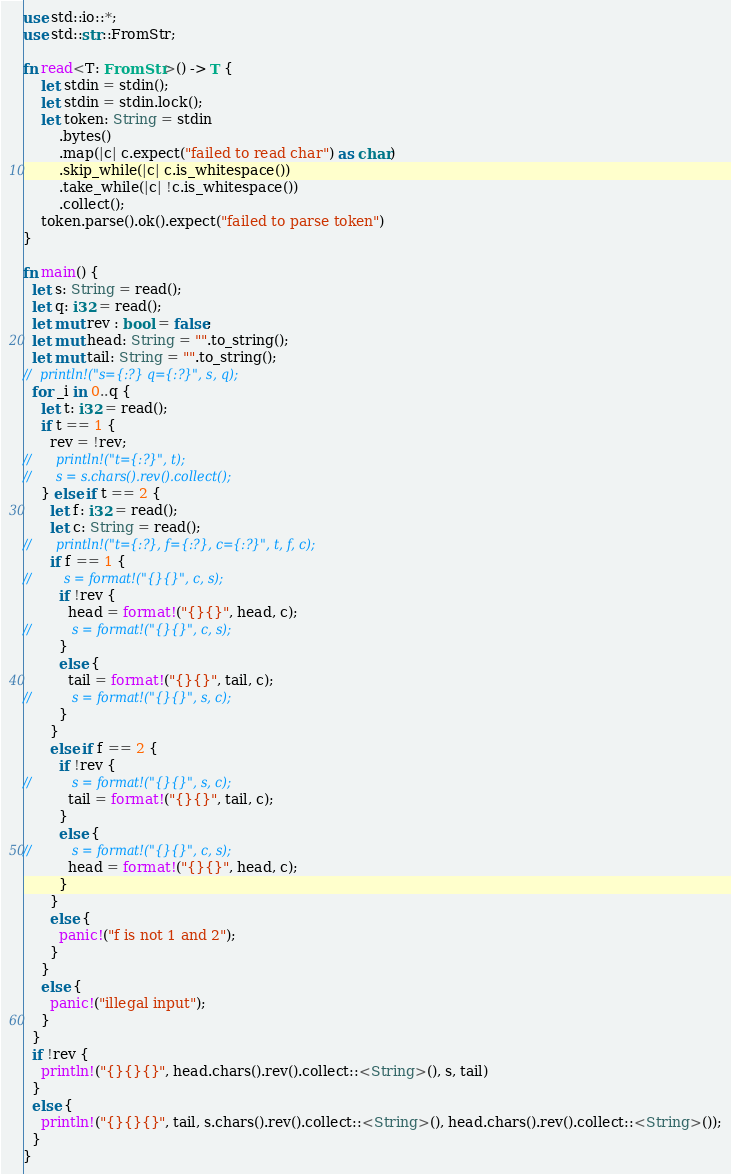Convert code to text. <code><loc_0><loc_0><loc_500><loc_500><_Rust_>use std::io::*;
use std::str::FromStr;

fn read<T: FromStr>() -> T {
    let stdin = stdin();
    let stdin = stdin.lock();
    let token: String = stdin
        .bytes()
        .map(|c| c.expect("failed to read char") as char)
        .skip_while(|c| c.is_whitespace())
        .take_while(|c| !c.is_whitespace())
        .collect();
    token.parse().ok().expect("failed to parse token")
}

fn main() {
  let s: String = read();
  let q: i32 = read();
  let mut rev : bool = false;
  let mut head: String = "".to_string();
  let mut tail: String = "".to_string();
//  println!("s={:?} q={:?}", s, q);
  for _i in 0..q {
    let t: i32 = read();
    if t == 1 {
      rev = !rev;
//      println!("t={:?}", t);
//      s = s.chars().rev().collect();
    } else if t == 2 {
      let f: i32 = read();
      let c: String = read();
//      println!("t={:?}, f={:?}, c={:?}", t, f, c);
      if f == 1 {
//        s = format!("{}{}", c, s);
        if !rev {
          head = format!("{}{}", head, c);
//          s = format!("{}{}", c, s);
        }
        else {
          tail = format!("{}{}", tail, c);
//          s = format!("{}{}", s, c);
        }
      }
      else if f == 2 {
        if !rev {
//          s = format!("{}{}", s, c);
          tail = format!("{}{}", tail, c);
        }
        else {
//          s = format!("{}{}", c, s);
          head = format!("{}{}", head, c);
        }
      }
      else {
        panic!("f is not 1 and 2");
      }
    }
    else {
      panic!("illegal input");
    }
  }
  if !rev {
    println!("{}{}{}", head.chars().rev().collect::<String>(), s, tail)
  }
  else {
    println!("{}{}{}", tail, s.chars().rev().collect::<String>(), head.chars().rev().collect::<String>());
  }
}
</code> 